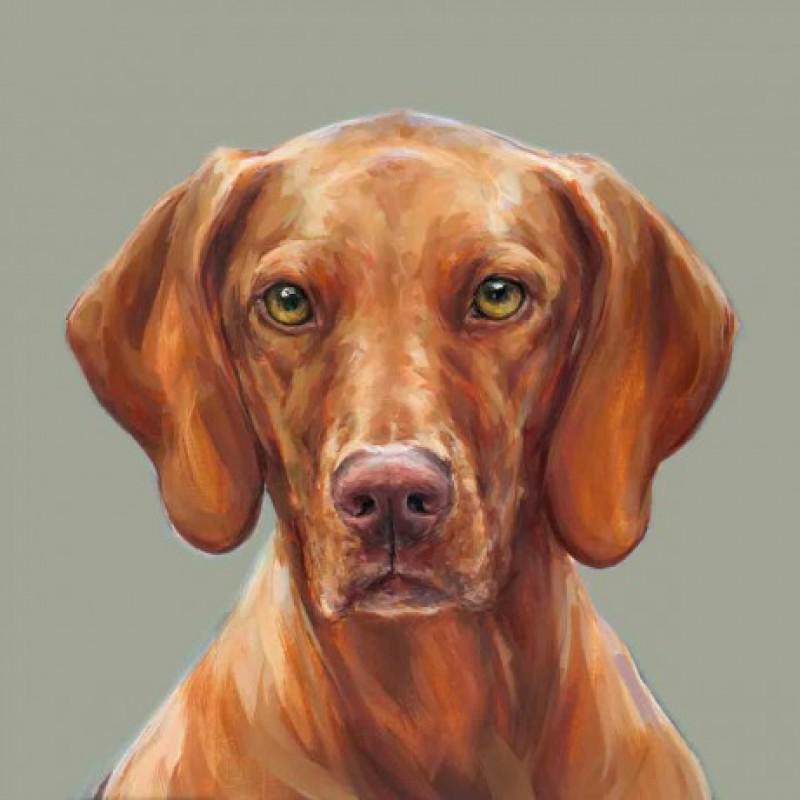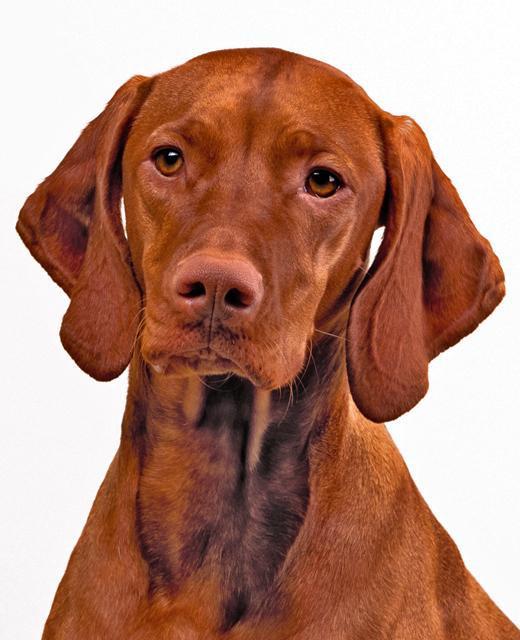The first image is the image on the left, the second image is the image on the right. Analyze the images presented: Is the assertion "At least one hound has a red collar around its neck." valid? Answer yes or no. No. The first image is the image on the left, the second image is the image on the right. For the images displayed, is the sentence "The left image contains one reddish-orange dog wearing a red braided cord around its neck." factually correct? Answer yes or no. No. 